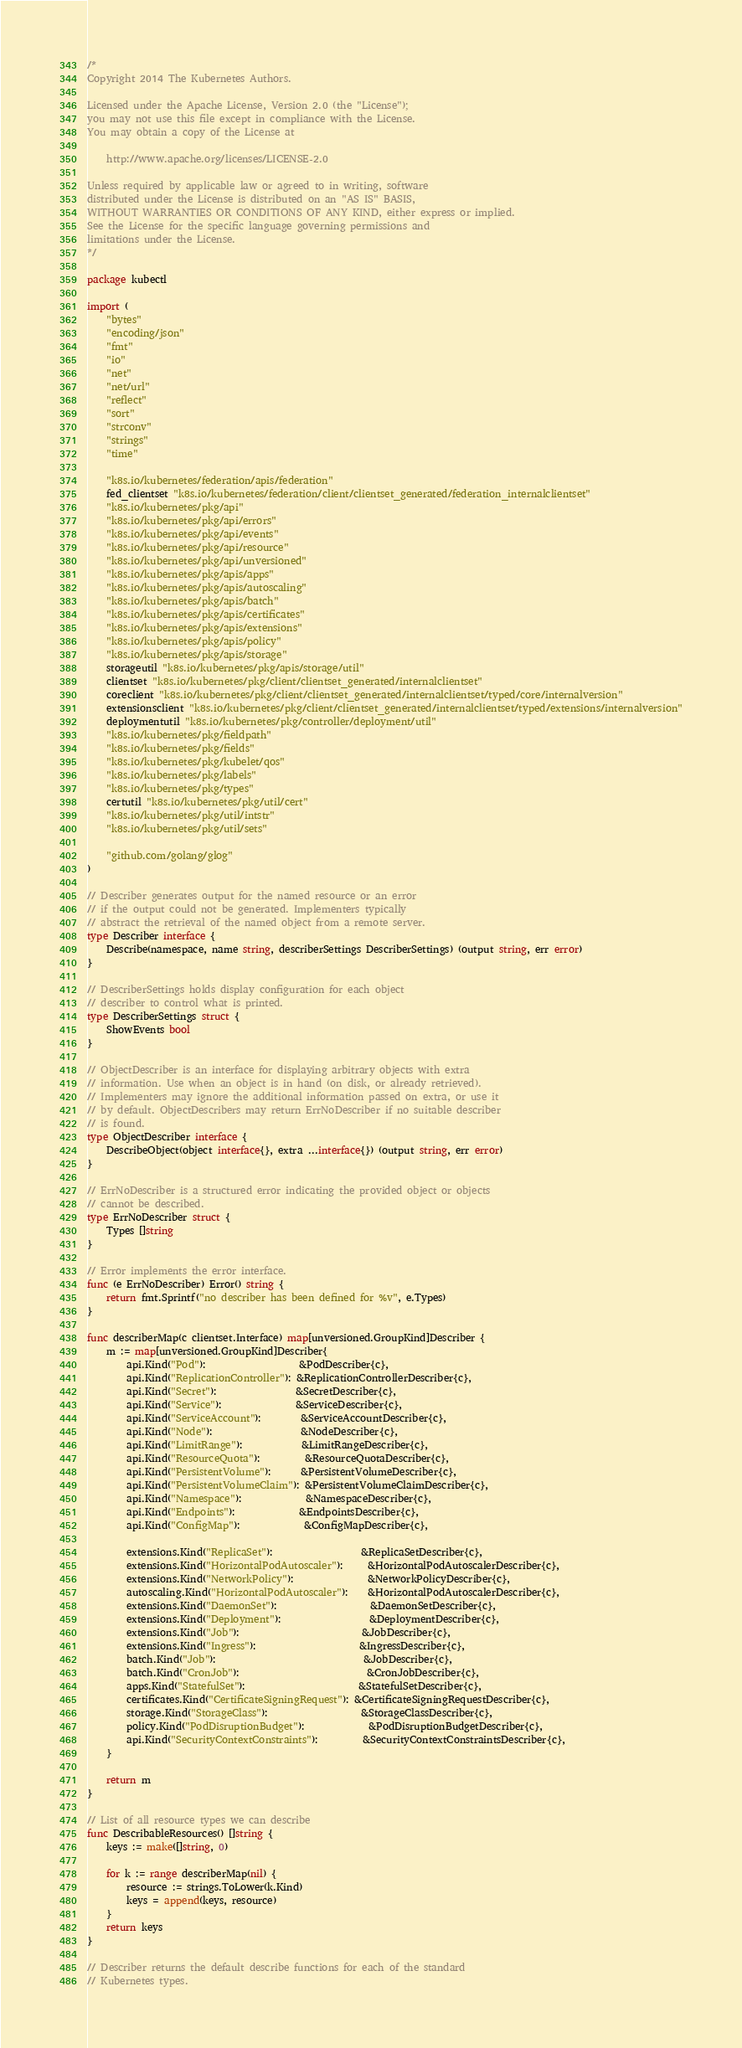Convert code to text. <code><loc_0><loc_0><loc_500><loc_500><_Go_>/*
Copyright 2014 The Kubernetes Authors.

Licensed under the Apache License, Version 2.0 (the "License");
you may not use this file except in compliance with the License.
You may obtain a copy of the License at

    http://www.apache.org/licenses/LICENSE-2.0

Unless required by applicable law or agreed to in writing, software
distributed under the License is distributed on an "AS IS" BASIS,
WITHOUT WARRANTIES OR CONDITIONS OF ANY KIND, either express or implied.
See the License for the specific language governing permissions and
limitations under the License.
*/

package kubectl

import (
	"bytes"
	"encoding/json"
	"fmt"
	"io"
	"net"
	"net/url"
	"reflect"
	"sort"
	"strconv"
	"strings"
	"time"

	"k8s.io/kubernetes/federation/apis/federation"
	fed_clientset "k8s.io/kubernetes/federation/client/clientset_generated/federation_internalclientset"
	"k8s.io/kubernetes/pkg/api"
	"k8s.io/kubernetes/pkg/api/errors"
	"k8s.io/kubernetes/pkg/api/events"
	"k8s.io/kubernetes/pkg/api/resource"
	"k8s.io/kubernetes/pkg/api/unversioned"
	"k8s.io/kubernetes/pkg/apis/apps"
	"k8s.io/kubernetes/pkg/apis/autoscaling"
	"k8s.io/kubernetes/pkg/apis/batch"
	"k8s.io/kubernetes/pkg/apis/certificates"
	"k8s.io/kubernetes/pkg/apis/extensions"
	"k8s.io/kubernetes/pkg/apis/policy"
	"k8s.io/kubernetes/pkg/apis/storage"
	storageutil "k8s.io/kubernetes/pkg/apis/storage/util"
	clientset "k8s.io/kubernetes/pkg/client/clientset_generated/internalclientset"
	coreclient "k8s.io/kubernetes/pkg/client/clientset_generated/internalclientset/typed/core/internalversion"
	extensionsclient "k8s.io/kubernetes/pkg/client/clientset_generated/internalclientset/typed/extensions/internalversion"
	deploymentutil "k8s.io/kubernetes/pkg/controller/deployment/util"
	"k8s.io/kubernetes/pkg/fieldpath"
	"k8s.io/kubernetes/pkg/fields"
	"k8s.io/kubernetes/pkg/kubelet/qos"
	"k8s.io/kubernetes/pkg/labels"
	"k8s.io/kubernetes/pkg/types"
	certutil "k8s.io/kubernetes/pkg/util/cert"
	"k8s.io/kubernetes/pkg/util/intstr"
	"k8s.io/kubernetes/pkg/util/sets"

	"github.com/golang/glog"
)

// Describer generates output for the named resource or an error
// if the output could not be generated. Implementers typically
// abstract the retrieval of the named object from a remote server.
type Describer interface {
	Describe(namespace, name string, describerSettings DescriberSettings) (output string, err error)
}

// DescriberSettings holds display configuration for each object
// describer to control what is printed.
type DescriberSettings struct {
	ShowEvents bool
}

// ObjectDescriber is an interface for displaying arbitrary objects with extra
// information. Use when an object is in hand (on disk, or already retrieved).
// Implementers may ignore the additional information passed on extra, or use it
// by default. ObjectDescribers may return ErrNoDescriber if no suitable describer
// is found.
type ObjectDescriber interface {
	DescribeObject(object interface{}, extra ...interface{}) (output string, err error)
}

// ErrNoDescriber is a structured error indicating the provided object or objects
// cannot be described.
type ErrNoDescriber struct {
	Types []string
}

// Error implements the error interface.
func (e ErrNoDescriber) Error() string {
	return fmt.Sprintf("no describer has been defined for %v", e.Types)
}

func describerMap(c clientset.Interface) map[unversioned.GroupKind]Describer {
	m := map[unversioned.GroupKind]Describer{
		api.Kind("Pod"):                   &PodDescriber{c},
		api.Kind("ReplicationController"): &ReplicationControllerDescriber{c},
		api.Kind("Secret"):                &SecretDescriber{c},
		api.Kind("Service"):               &ServiceDescriber{c},
		api.Kind("ServiceAccount"):        &ServiceAccountDescriber{c},
		api.Kind("Node"):                  &NodeDescriber{c},
		api.Kind("LimitRange"):            &LimitRangeDescriber{c},
		api.Kind("ResourceQuota"):         &ResourceQuotaDescriber{c},
		api.Kind("PersistentVolume"):      &PersistentVolumeDescriber{c},
		api.Kind("PersistentVolumeClaim"): &PersistentVolumeClaimDescriber{c},
		api.Kind("Namespace"):             &NamespaceDescriber{c},
		api.Kind("Endpoints"):             &EndpointsDescriber{c},
		api.Kind("ConfigMap"):             &ConfigMapDescriber{c},

		extensions.Kind("ReplicaSet"):                  &ReplicaSetDescriber{c},
		extensions.Kind("HorizontalPodAutoscaler"):     &HorizontalPodAutoscalerDescriber{c},
		extensions.Kind("NetworkPolicy"):               &NetworkPolicyDescriber{c},
		autoscaling.Kind("HorizontalPodAutoscaler"):    &HorizontalPodAutoscalerDescriber{c},
		extensions.Kind("DaemonSet"):                   &DaemonSetDescriber{c},
		extensions.Kind("Deployment"):                  &DeploymentDescriber{c},
		extensions.Kind("Job"):                         &JobDescriber{c},
		extensions.Kind("Ingress"):                     &IngressDescriber{c},
		batch.Kind("Job"):                              &JobDescriber{c},
		batch.Kind("CronJob"):                          &CronJobDescriber{c},
		apps.Kind("StatefulSet"):                       &StatefulSetDescriber{c},
		certificates.Kind("CertificateSigningRequest"): &CertificateSigningRequestDescriber{c},
		storage.Kind("StorageClass"):                   &StorageClassDescriber{c},
		policy.Kind("PodDisruptionBudget"):             &PodDisruptionBudgetDescriber{c},
		api.Kind("SecurityContextConstraints"):         &SecurityContextConstraintsDescriber{c},
	}

	return m
}

// List of all resource types we can describe
func DescribableResources() []string {
	keys := make([]string, 0)

	for k := range describerMap(nil) {
		resource := strings.ToLower(k.Kind)
		keys = append(keys, resource)
	}
	return keys
}

// Describer returns the default describe functions for each of the standard
// Kubernetes types.</code> 